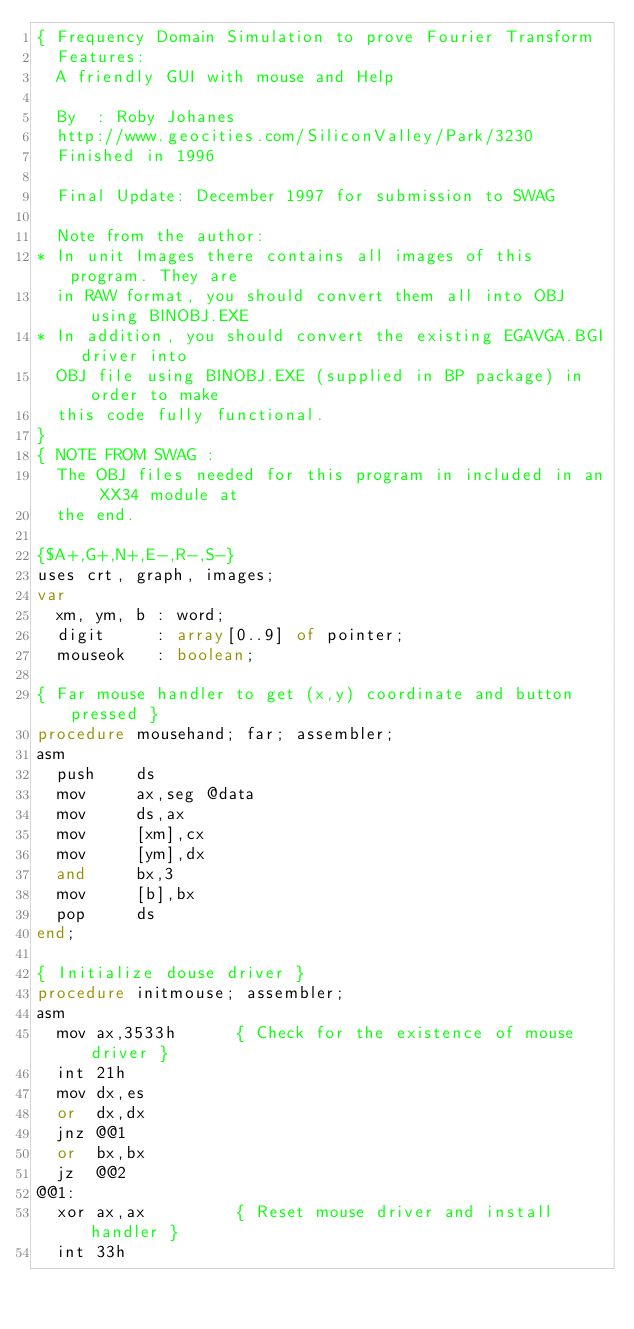<code> <loc_0><loc_0><loc_500><loc_500><_Pascal_>{ Frequency Domain Simulation to prove Fourier Transform
  Features:
  A friendly GUI with mouse and Help

  By  : Roby Johanes
  http://www.geocities.com/SiliconValley/Park/3230
  Finished in 1996

  Final Update: December 1997 for submission to SWAG

  Note from the author:
* In unit Images there contains all images of this program. They are
  in RAW format, you should convert them all into OBJ using BINOBJ.EXE
* In addition, you should convert the existing EGAVGA.BGI driver into
  OBJ file using BINOBJ.EXE (supplied in BP package) in order to make
  this code fully functional.
}
{ NOTE FROM SWAG :
  The OBJ files needed for this program in included in an XX34 module at
  the end.

{$A+,G+,N+,E-,R-,S-}
uses crt, graph, images;
var
  xm, ym, b : word;
  digit     : array[0..9] of pointer;
  mouseok   : boolean;

{ Far mouse handler to get (x,y) coordinate and button pressed }
procedure mousehand; far; assembler;
asm
  push    ds
  mov     ax,seg @data
  mov     ds,ax
  mov     [xm],cx
  mov     [ym],dx
  and     bx,3
  mov     [b],bx
  pop     ds
end;

{ Initialize douse driver }
procedure initmouse; assembler;
asm
  mov ax,3533h      { Check for the existence of mouse driver }
  int 21h
  mov dx,es
  or  dx,dx
  jnz @@1
  or  bx,bx
  jz  @@2
@@1:
  xor ax,ax         { Reset mouse driver and install handler }
  int 33h</code> 